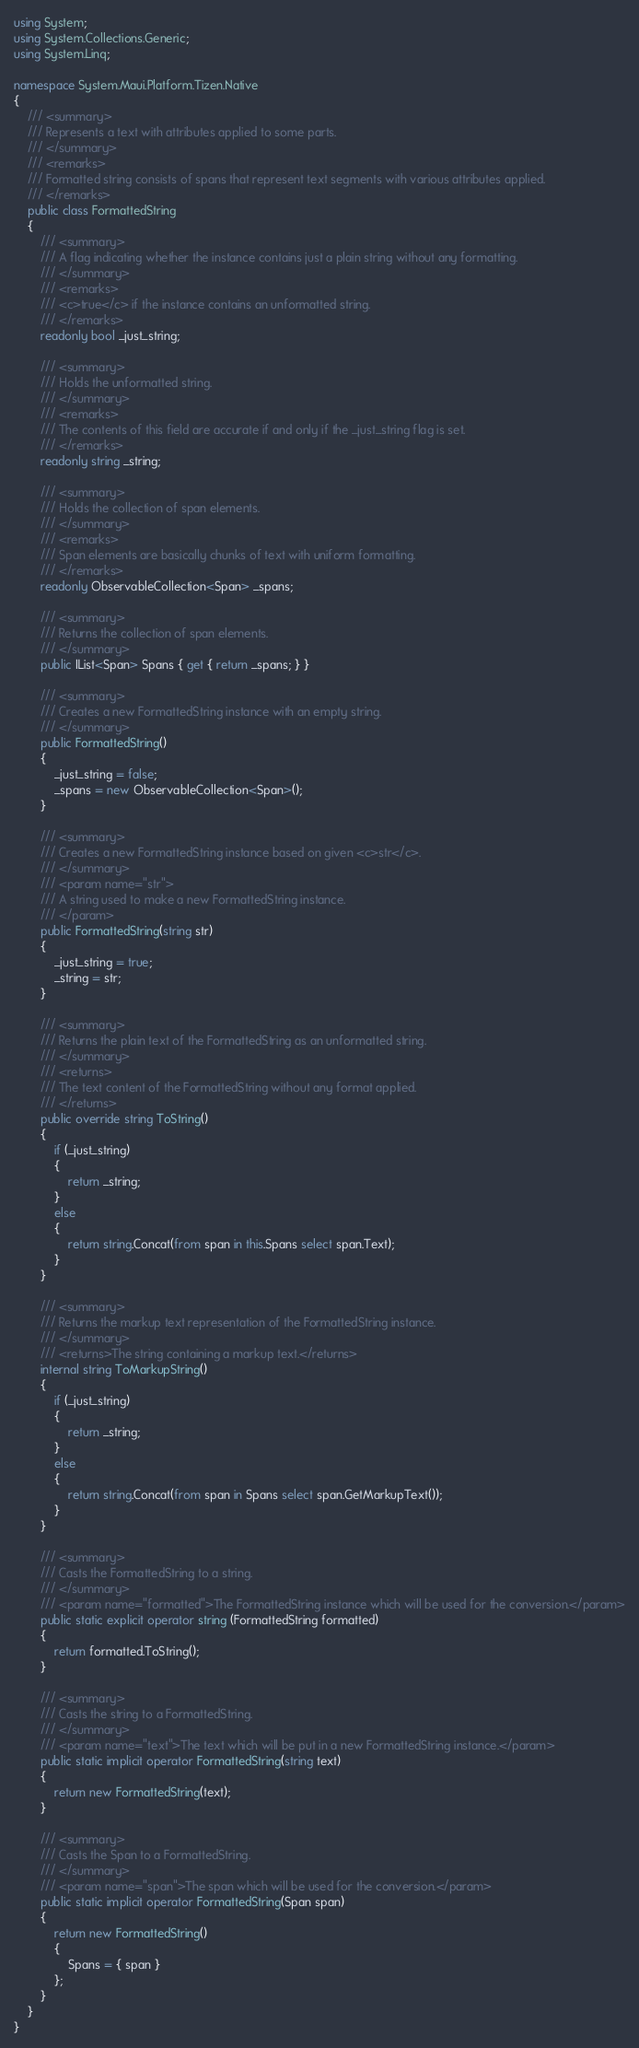<code> <loc_0><loc_0><loc_500><loc_500><_C#_>using System;
using System.Collections.Generic;
using System.Linq;

namespace System.Maui.Platform.Tizen.Native
{
	/// <summary>
	/// Represents a text with attributes applied to some parts.
	/// </summary>
	/// <remarks>
	/// Formatted string consists of spans that represent text segments with various attributes applied.
	/// </remarks>
	public class FormattedString
	{
		/// <summary>
		/// A flag indicating whether the instance contains just a plain string without any formatting.
		/// </summary>
		/// <remarks>
		/// <c>true</c> if the instance contains an unformatted string.
		/// </remarks>
		readonly bool _just_string;

		/// <summary>
		/// Holds the unformatted string.
		/// </summary>
		/// <remarks>
		/// The contents of this field are accurate if and only if the _just_string flag is set.
		/// </remarks>
		readonly string _string;

		/// <summary>
		/// Holds the collection of span elements.
		/// </summary>
		/// <remarks>
		/// Span elements are basically chunks of text with uniform formatting.
		/// </remarks>
		readonly ObservableCollection<Span> _spans;

		/// <summary>
		/// Returns the collection of span elements.
		/// </summary>
		public IList<Span> Spans { get { return _spans; } }

		/// <summary>
		/// Creates a new FormattedString instance with an empty string.
		/// </summary>
		public FormattedString()
		{
			_just_string = false;
			_spans = new ObservableCollection<Span>();
		}

		/// <summary>
		/// Creates a new FormattedString instance based on given <c>str</c>.
		/// </summary>
		/// <param name="str">
		/// A string used to make a new FormattedString instance.
		/// </param>
		public FormattedString(string str)
		{
			_just_string = true;
			_string = str;
		}

		/// <summary>
		/// Returns the plain text of the FormattedString as an unformatted string.
		/// </summary>
		/// <returns>
		/// The text content of the FormattedString without any format applied.
		/// </returns>
		public override string ToString()
		{
			if (_just_string)
			{
				return _string;
			}
			else
			{
				return string.Concat(from span in this.Spans select span.Text);
			}
		}

		/// <summary>
		/// Returns the markup text representation of the FormattedString instance.
		/// </summary>
		/// <returns>The string containing a markup text.</returns>
		internal string ToMarkupString()
		{
			if (_just_string)
			{
				return _string;
			}
			else
			{
				return string.Concat(from span in Spans select span.GetMarkupText());
			}
		}

		/// <summary>
		/// Casts the FormattedString to a string.
		/// </summary>
		/// <param name="formatted">The FormattedString instance which will be used for the conversion.</param>
		public static explicit operator string (FormattedString formatted)
		{
			return formatted.ToString();
		}

		/// <summary>
		/// Casts the string to a FormattedString.
		/// </summary>
		/// <param name="text">The text which will be put in a new FormattedString instance.</param>
		public static implicit operator FormattedString(string text)
		{
			return new FormattedString(text);
		}

		/// <summary>
		/// Casts the Span to a FormattedString.
		/// </summary>
		/// <param name="span">The span which will be used for the conversion.</param>
		public static implicit operator FormattedString(Span span)
		{
			return new FormattedString()
			{
				Spans = { span }
			};
		}
	}
}
</code> 